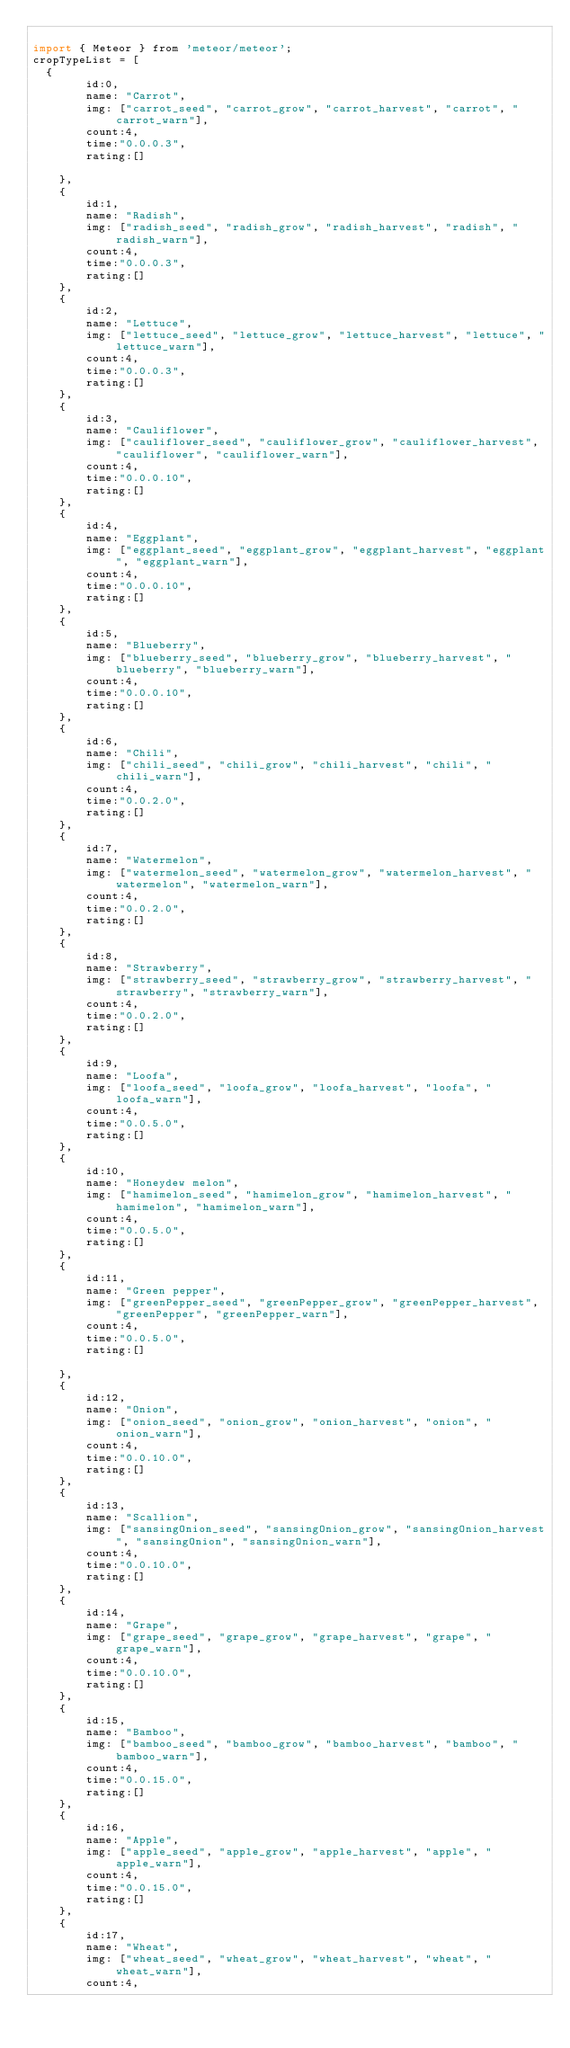<code> <loc_0><loc_0><loc_500><loc_500><_JavaScript_>
import { Meteor } from 'meteor/meteor';
cropTypeList = [
  {
        id:0,
        name: "Carrot",
        img: ["carrot_seed", "carrot_grow", "carrot_harvest", "carrot", "carrot_warn"],
        count:4,
        time:"0.0.0.3",
        rating:[]

    },
    {
        id:1,
        name: "Radish",
        img: ["radish_seed", "radish_grow", "radish_harvest", "radish", "radish_warn"],
        count:4,
        time:"0.0.0.3",
        rating:[]
    },
    {
        id:2,
        name: "Lettuce",
        img: ["lettuce_seed", "lettuce_grow", "lettuce_harvest", "lettuce", "lettuce_warn"],
        count:4,
        time:"0.0.0.3",
        rating:[]
    },
    {
        id:3,
        name: "Cauliflower",
        img: ["cauliflower_seed", "cauliflower_grow", "cauliflower_harvest", "cauliflower", "cauliflower_warn"],
        count:4,
        time:"0.0.0.10",
        rating:[]
    },
    {
        id:4,
        name: "Eggplant",
        img: ["eggplant_seed", "eggplant_grow", "eggplant_harvest", "eggplant", "eggplant_warn"],
        count:4,
        time:"0.0.0.10",
        rating:[]
    },
    {
        id:5,
        name: "Blueberry",
        img: ["blueberry_seed", "blueberry_grow", "blueberry_harvest", "blueberry", "blueberry_warn"],
        count:4,
        time:"0.0.0.10",
        rating:[]
    },
    {
        id:6,
        name: "Chili",
        img: ["chili_seed", "chili_grow", "chili_harvest", "chili", "chili_warn"],
        count:4,
        time:"0.0.2.0",
        rating:[]
    },
    {
        id:7,
        name: "Watermelon",
        img: ["watermelon_seed", "watermelon_grow", "watermelon_harvest", "watermelon", "watermelon_warn"],
        count:4,
        time:"0.0.2.0",
        rating:[]
    },
    {
        id:8,
        name: "Strawberry",
        img: ["strawberry_seed", "strawberry_grow", "strawberry_harvest", "strawberry", "strawberry_warn"],
        count:4,
        time:"0.0.2.0",
        rating:[]
    },
    {
        id:9,
        name: "Loofa",
        img: ["loofa_seed", "loofa_grow", "loofa_harvest", "loofa", "loofa_warn"],
        count:4,
        time:"0.0.5.0",
        rating:[]
    },
    {
        id:10,
        name: "Honeydew melon",
        img: ["hamimelon_seed", "hamimelon_grow", "hamimelon_harvest", "hamimelon", "hamimelon_warn"],
        count:4,
        time:"0.0.5.0",
        rating:[]
    },
    {
        id:11,
        name: "Green pepper",
        img: ["greenPepper_seed", "greenPepper_grow", "greenPepper_harvest", "greenPepper", "greenPepper_warn"],
        count:4,
        time:"0.0.5.0",
        rating:[]

    },
    {
        id:12,
        name: "Onion",
        img: ["onion_seed", "onion_grow", "onion_harvest", "onion", "onion_warn"],
        count:4,
        time:"0.0.10.0",
        rating:[]
    },
    {
        id:13,
        name: "Scallion",
        img: ["sansingOnion_seed", "sansingOnion_grow", "sansingOnion_harvest", "sansingOnion", "sansingOnion_warn"],
        count:4,
        time:"0.0.10.0",
        rating:[]
    },
    {
        id:14,
        name: "Grape",
        img: ["grape_seed", "grape_grow", "grape_harvest", "grape", "grape_warn"],
        count:4,
        time:"0.0.10.0",
        rating:[]
    },
    {
        id:15,
        name: "Bamboo",
        img: ["bamboo_seed", "bamboo_grow", "bamboo_harvest", "bamboo", "bamboo_warn"],
        count:4,
        time:"0.0.15.0",
        rating:[]
    },
    {
        id:16,
        name: "Apple",
        img: ["apple_seed", "apple_grow", "apple_harvest", "apple", "apple_warn"],
        count:4,
        time:"0.0.15.0",
        rating:[]
    },
    {
        id:17,
        name: "Wheat",
        img: ["wheat_seed", "wheat_grow", "wheat_harvest", "wheat", "wheat_warn"],
        count:4,</code> 